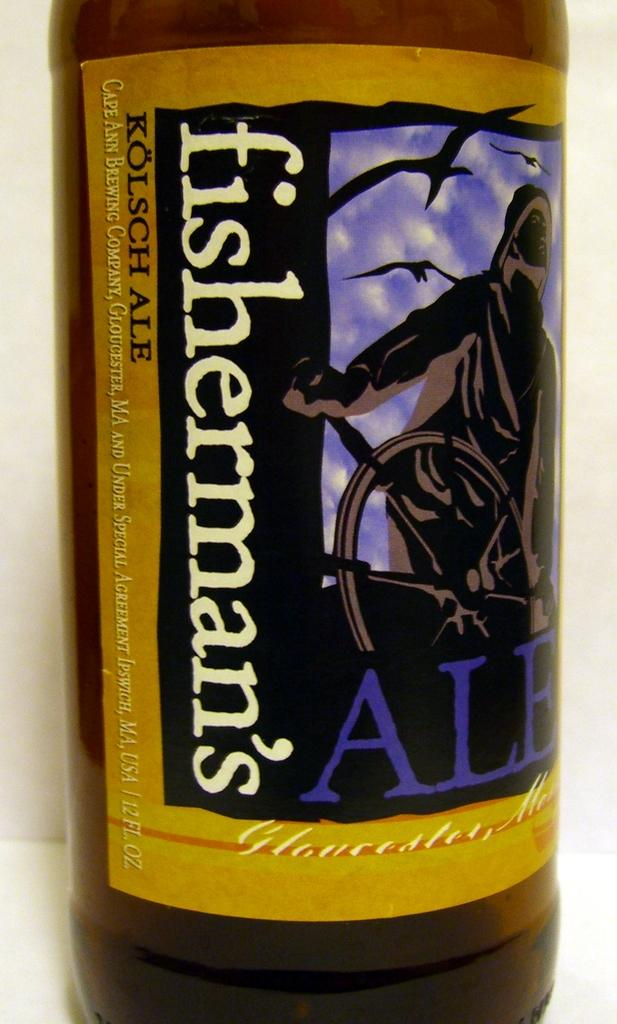<image>
Share a concise interpretation of the image provided. A close up of a label that says fisherman's ale. 